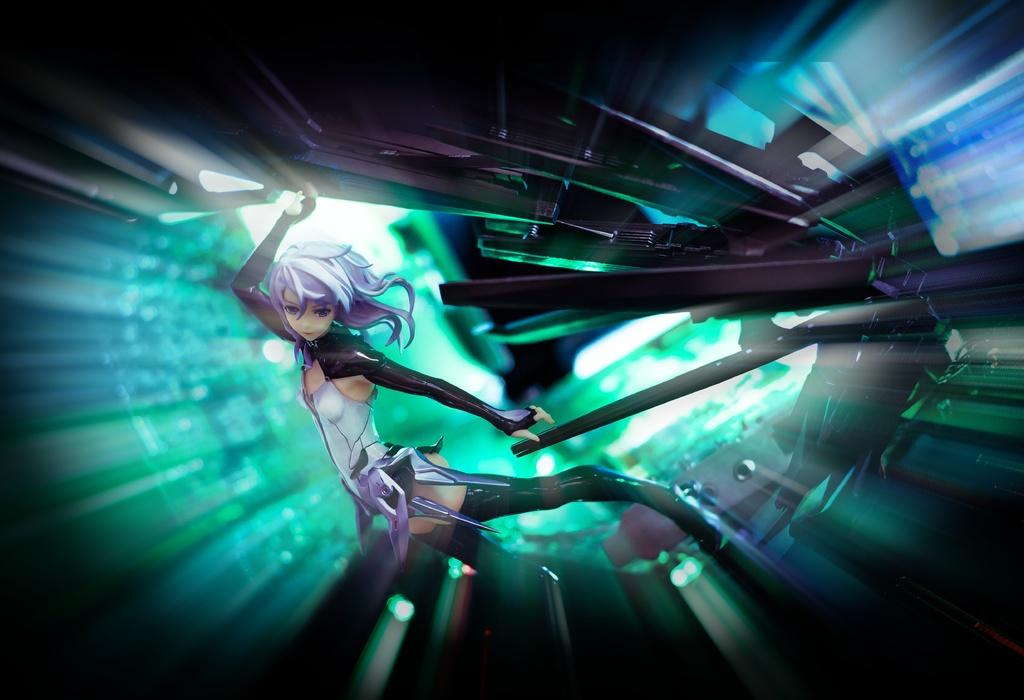Who is the main subject in the image? There is a woman in the image. What is the woman doing in the image? The woman appears to be standing. What can be seen in the background of the image? There are objects in the background of the image. Can you describe the lighting in the image? There is light visible in the image. How many lizards can be seen interacting with the woman in the image? There are no lizards present in the image. What type of memory does the woman have in the image? The image does not provide information about the woman's memory. 